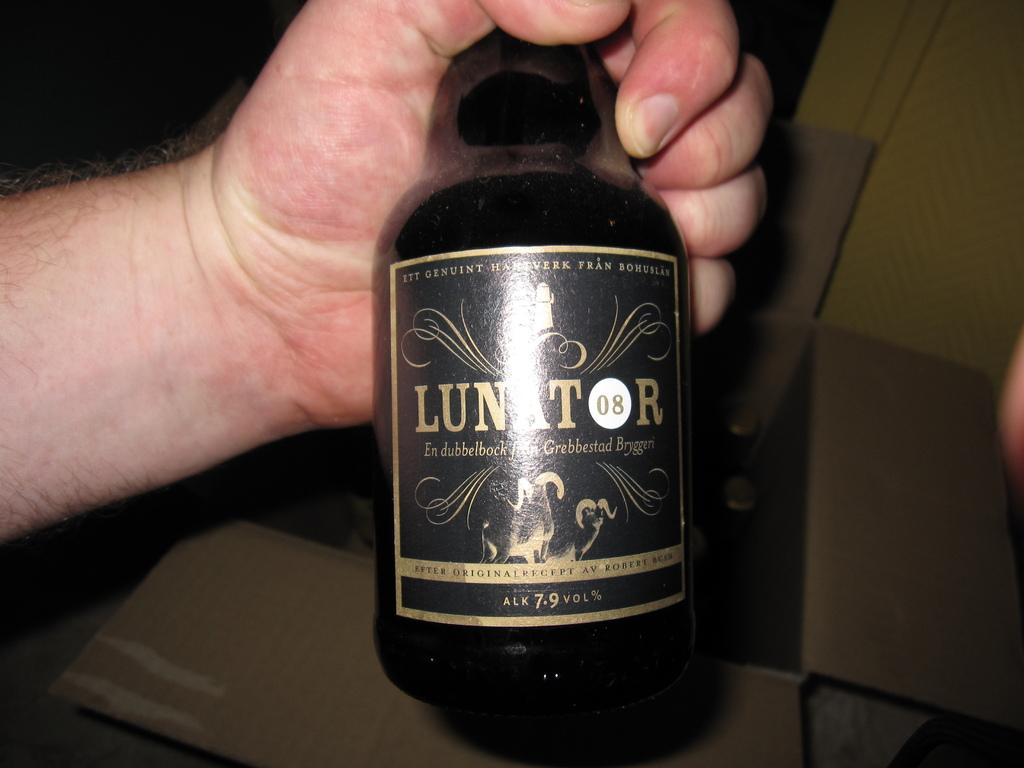<image>
Provide a brief description of the given image. A bottle of Lunator is held by the neck in someone's hand. 